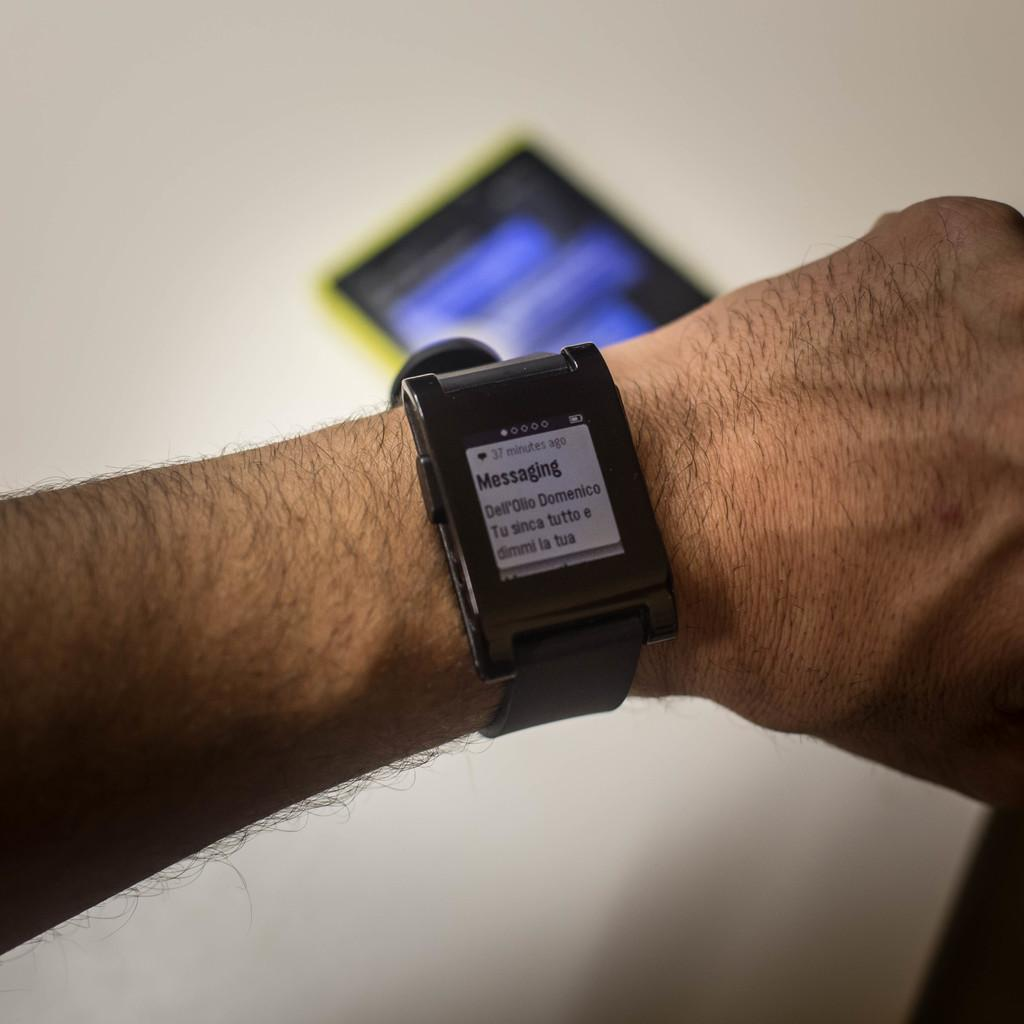What accessory is worn on the person's wrist in the image? There is a wristwatch on a person's wrist in the image. What electronic device is visible behind the hand in the image? There is a mobile phone visible behind the hand in the image. What type of furniture is present in the image? There is no furniture visible in the image; it only shows a wristwatch on a person's wrist and a mobile phone behind the hand. 